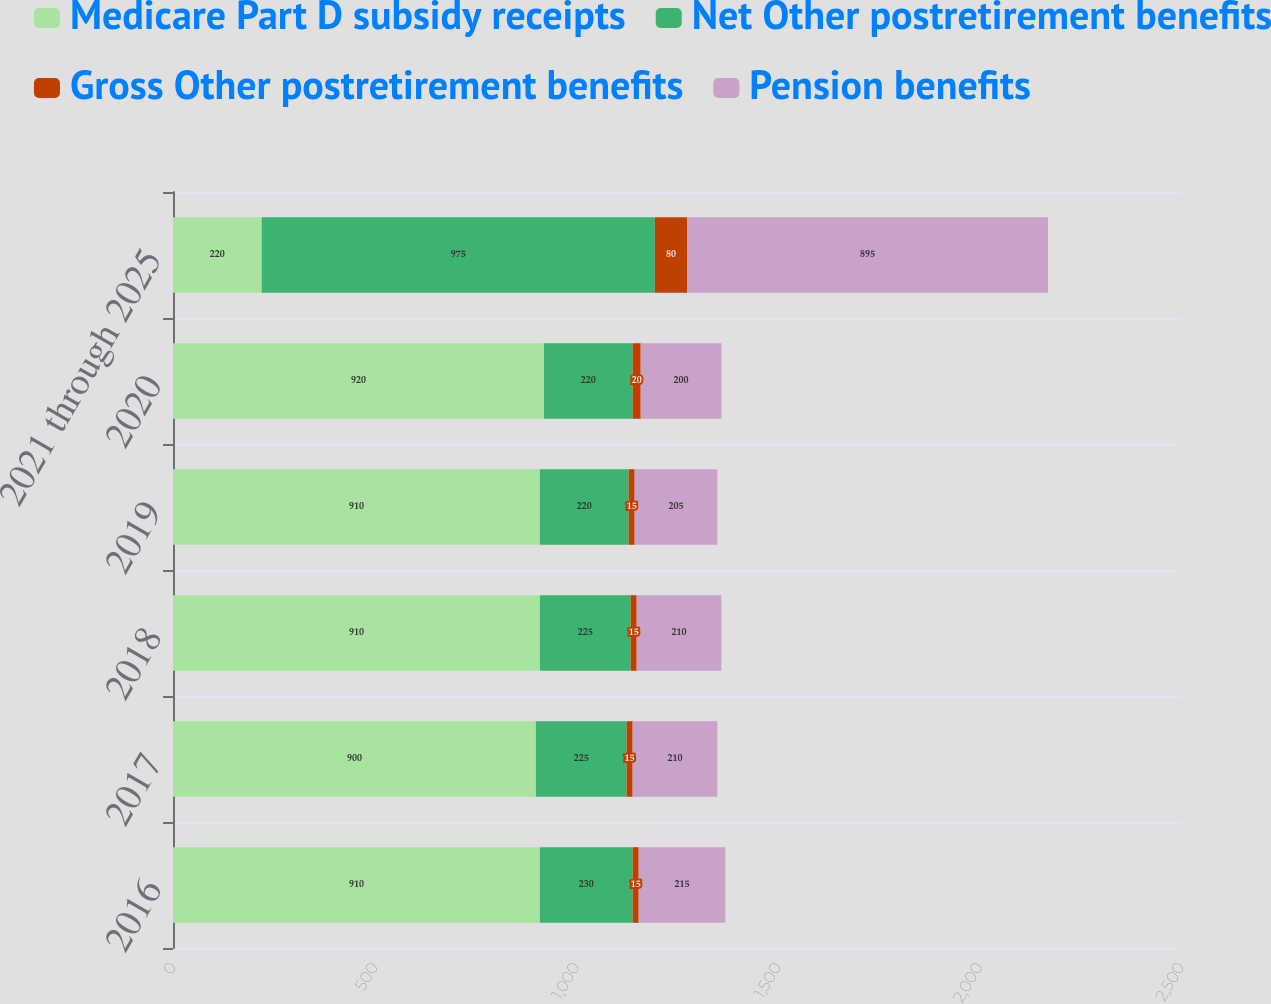Convert chart to OTSL. <chart><loc_0><loc_0><loc_500><loc_500><stacked_bar_chart><ecel><fcel>2016<fcel>2017<fcel>2018<fcel>2019<fcel>2020<fcel>2021 through 2025<nl><fcel>Medicare Part D subsidy receipts<fcel>910<fcel>900<fcel>910<fcel>910<fcel>920<fcel>220<nl><fcel>Net Other postretirement benefits<fcel>230<fcel>225<fcel>225<fcel>220<fcel>220<fcel>975<nl><fcel>Gross Other postretirement benefits<fcel>15<fcel>15<fcel>15<fcel>15<fcel>20<fcel>80<nl><fcel>Pension benefits<fcel>215<fcel>210<fcel>210<fcel>205<fcel>200<fcel>895<nl></chart> 